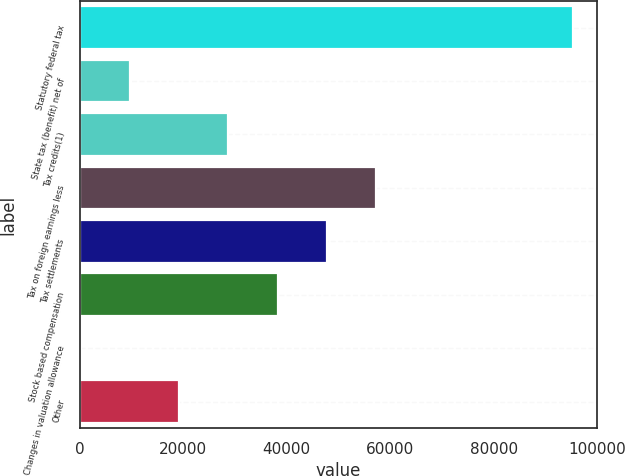Convert chart. <chart><loc_0><loc_0><loc_500><loc_500><bar_chart><fcel>Statutory federal tax<fcel>State tax (benefit) net of<fcel>Tax credits(1)<fcel>Tax on foreign earnings less<fcel>Tax settlements<fcel>Stock based compensation<fcel>Changes in valuation allowance<fcel>Other<nl><fcel>95251<fcel>9736.6<fcel>28739.8<fcel>57244.6<fcel>47743<fcel>38241.4<fcel>235<fcel>19238.2<nl></chart> 